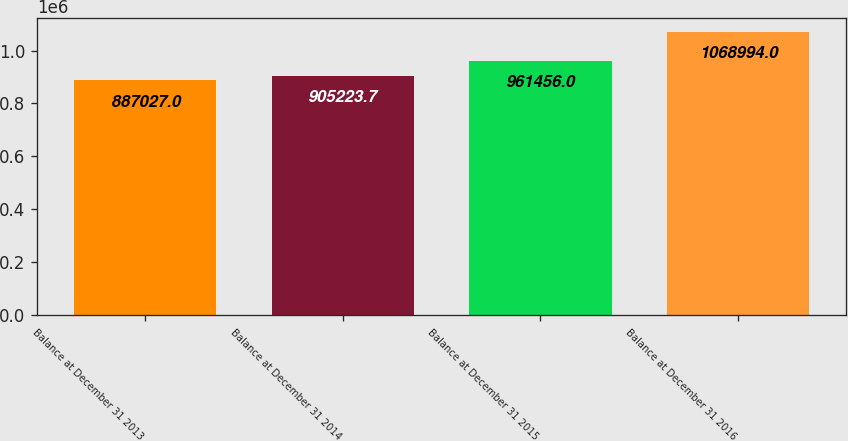Convert chart to OTSL. <chart><loc_0><loc_0><loc_500><loc_500><bar_chart><fcel>Balance at December 31 2013<fcel>Balance at December 31 2014<fcel>Balance at December 31 2015<fcel>Balance at December 31 2016<nl><fcel>887027<fcel>905224<fcel>961456<fcel>1.06899e+06<nl></chart> 